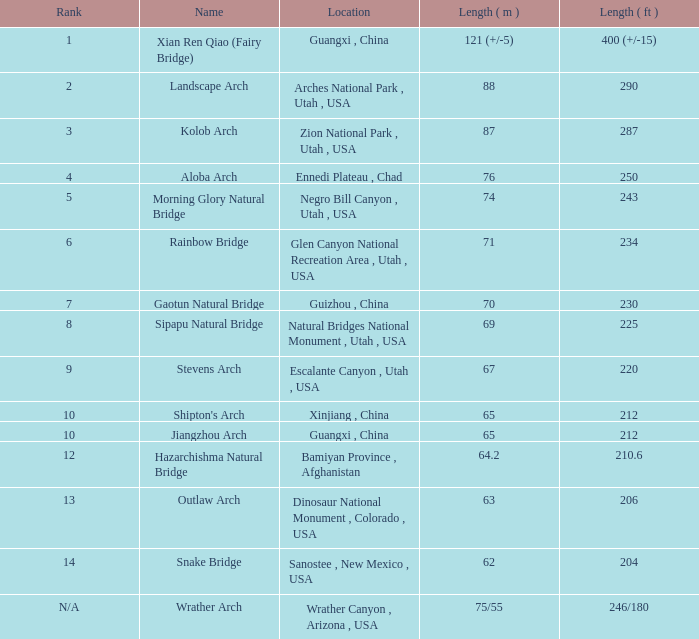Where is the 63-meter long arch that is the longest? Dinosaur National Monument , Colorado , USA. 